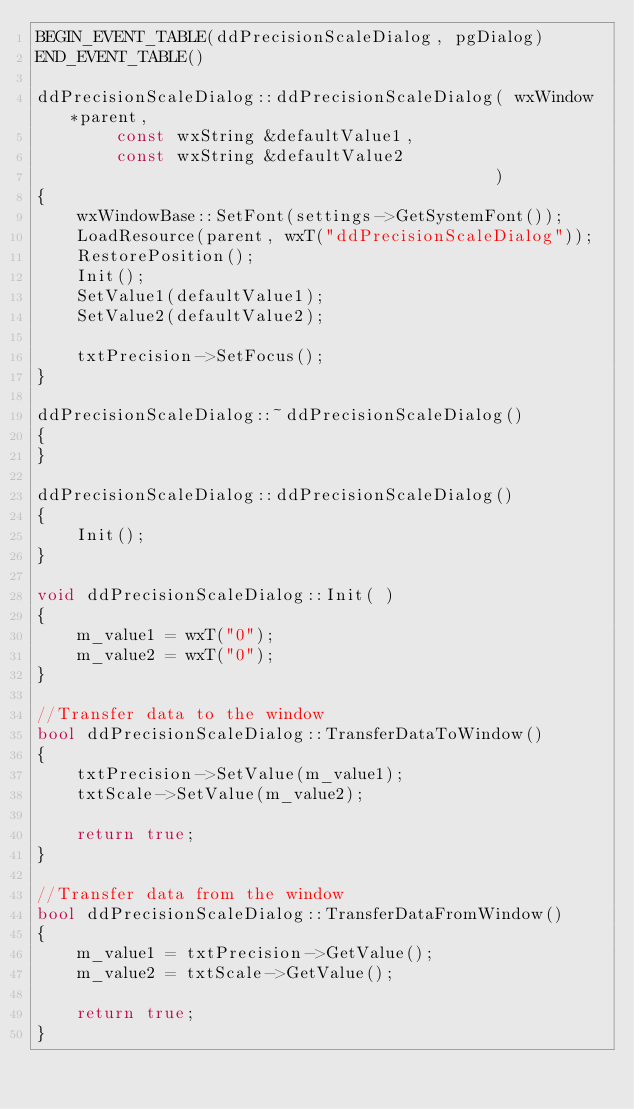<code> <loc_0><loc_0><loc_500><loc_500><_C++_>BEGIN_EVENT_TABLE(ddPrecisionScaleDialog, pgDialog)
END_EVENT_TABLE()

ddPrecisionScaleDialog::ddPrecisionScaleDialog(	wxWindow *parent,
        const wxString &defaultValue1,
        const wxString &defaultValue2
                                              )
{
	wxWindowBase::SetFont(settings->GetSystemFont());
	LoadResource(parent, wxT("ddPrecisionScaleDialog"));
	RestorePosition();
	Init();
	SetValue1(defaultValue1);
	SetValue2(defaultValue2);

	txtPrecision->SetFocus();
}

ddPrecisionScaleDialog::~ddPrecisionScaleDialog()
{
}

ddPrecisionScaleDialog::ddPrecisionScaleDialog()
{
	Init();
}

void ddPrecisionScaleDialog::Init( )
{
	m_value1 = wxT("0");
	m_value2 = wxT("0");
}

//Transfer data to the window
bool ddPrecisionScaleDialog::TransferDataToWindow()
{
	txtPrecision->SetValue(m_value1);
	txtScale->SetValue(m_value2);

	return true;
}

//Transfer data from the window
bool ddPrecisionScaleDialog::TransferDataFromWindow()
{
	m_value1 = txtPrecision->GetValue();
	m_value2 = txtScale->GetValue();

	return true;
}
</code> 